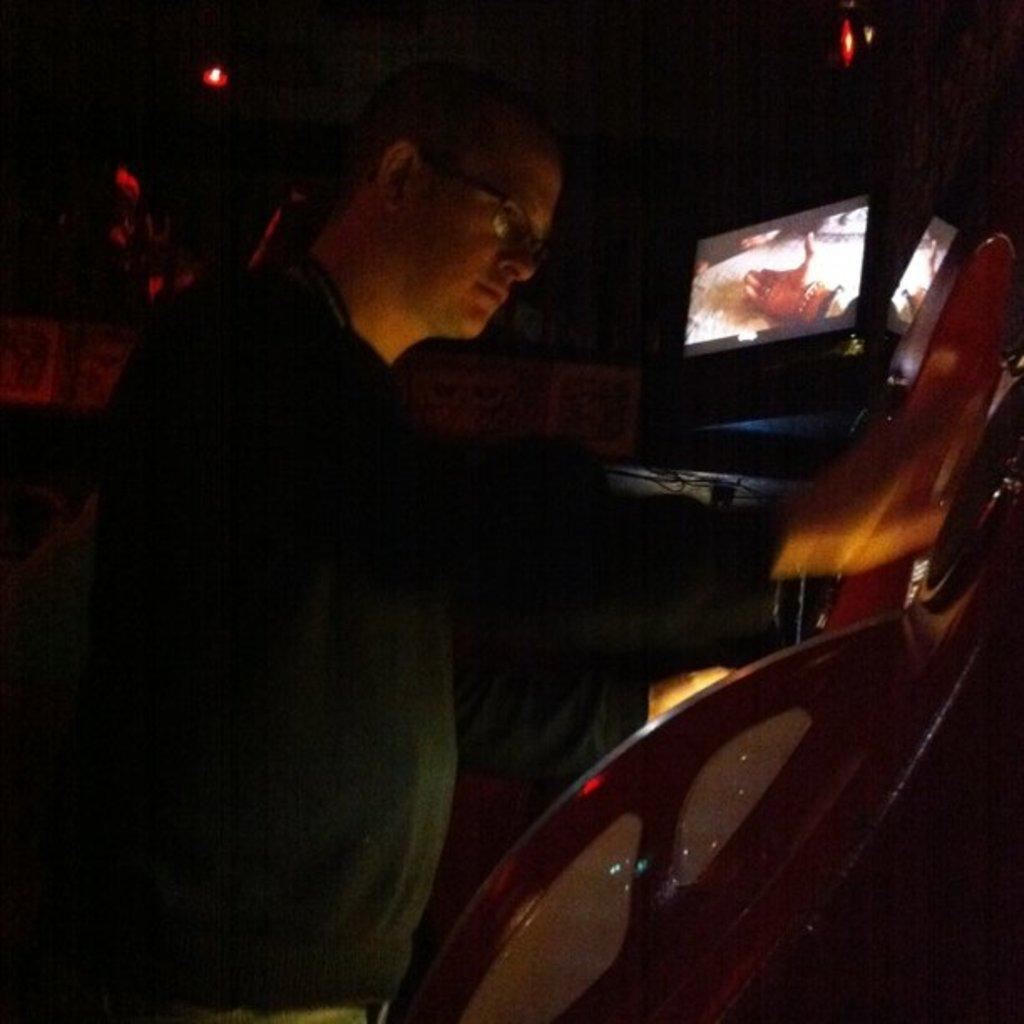What is located in the front of the image? There is a person and an object in the front of the image. Can you describe the person in the image? Unfortunately, the provided facts do not give any details about the person's appearance or clothing. What can be seen in the background of the image? In the background of the image, there are lights, screens, and other objects. How many screens are visible in the background? The provided facts do not specify the exact number of screens visible in the background. What type of rat is sitting on the yoke in the image? There is no rat or yoke present in the image. How does the ball interact with the person in the image? There is no ball present in the image, so it cannot interact with the person. 